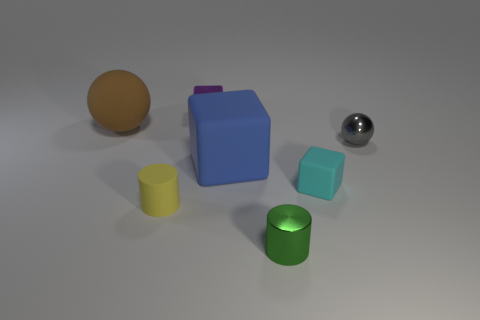How is the lighting arranged in the scene? The lighting in the scene appears to be diffuse overhead light, creating soft shadows beneath the objects suggesting a light source above and possibly slightly in front of the objects. 